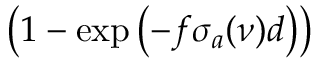Convert formula to latex. <formula><loc_0><loc_0><loc_500><loc_500>\left ( 1 - \exp { \left ( - f \sigma _ { a } ( \nu ) d \right ) } \right )</formula> 